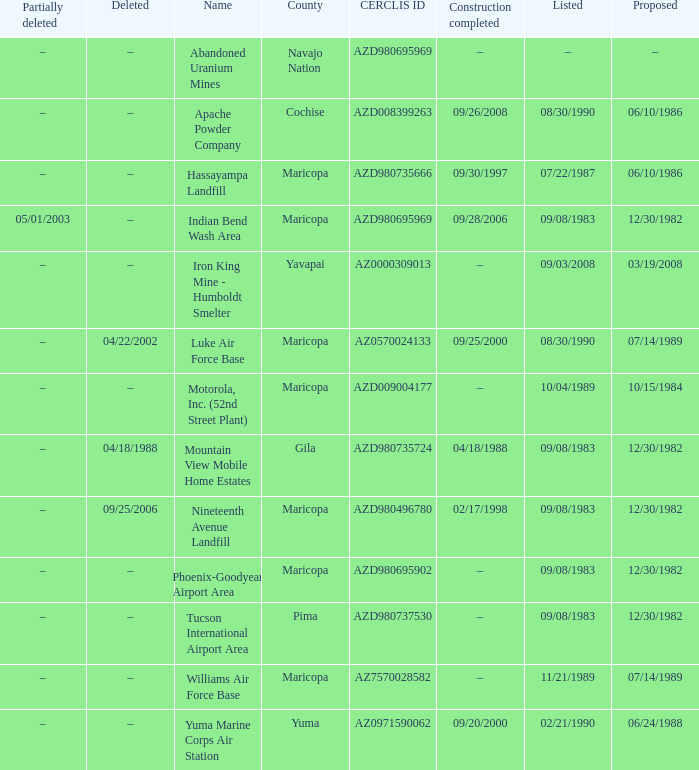When was the site listed when the county is cochise? 08/30/1990. 